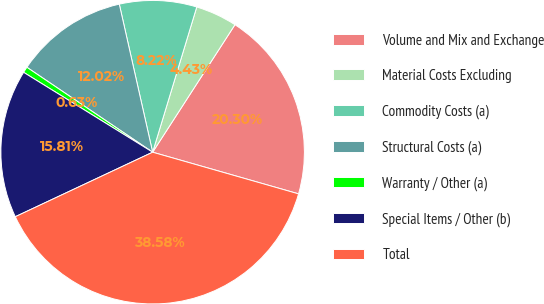Convert chart to OTSL. <chart><loc_0><loc_0><loc_500><loc_500><pie_chart><fcel>Volume and Mix and Exchange<fcel>Material Costs Excluding<fcel>Commodity Costs (a)<fcel>Structural Costs (a)<fcel>Warranty / Other (a)<fcel>Special Items / Other (b)<fcel>Total<nl><fcel>20.3%<fcel>4.43%<fcel>8.22%<fcel>12.02%<fcel>0.63%<fcel>15.81%<fcel>38.58%<nl></chart> 